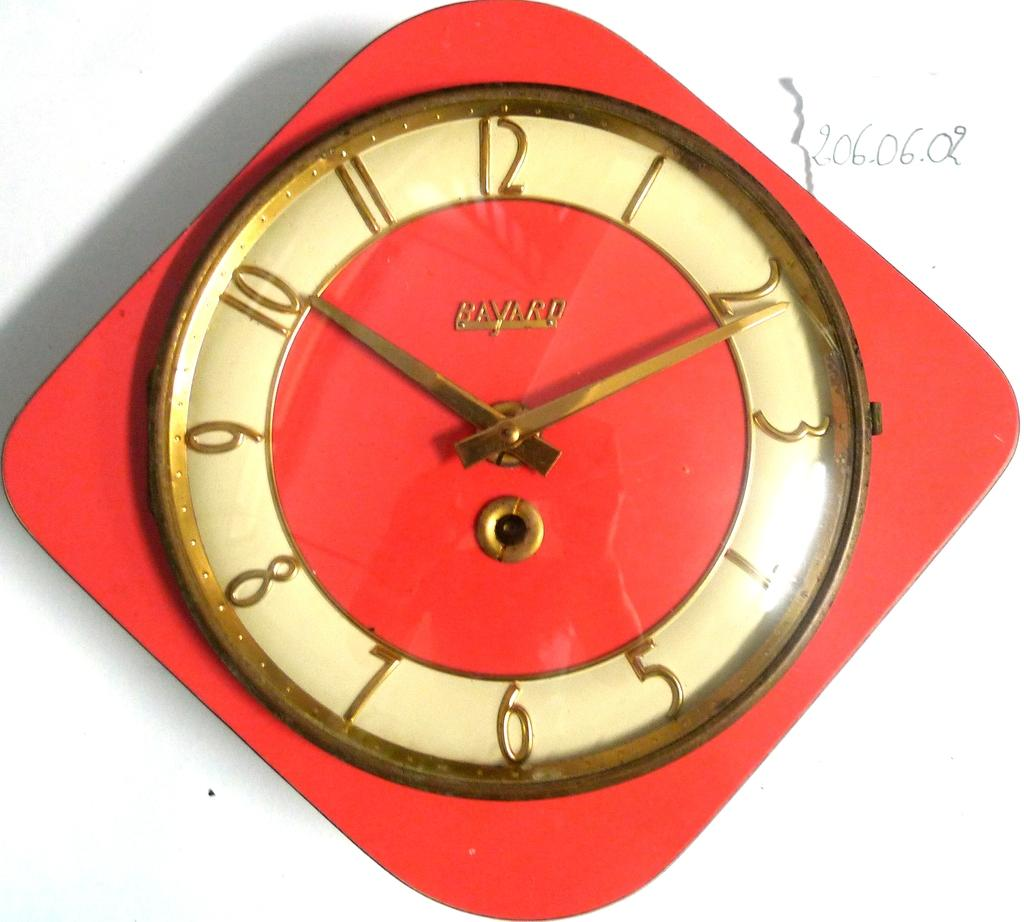Provide a one-sentence caption for the provided image. a BAVARD brand name old red wall clock with gold numbers, hands and trim. 